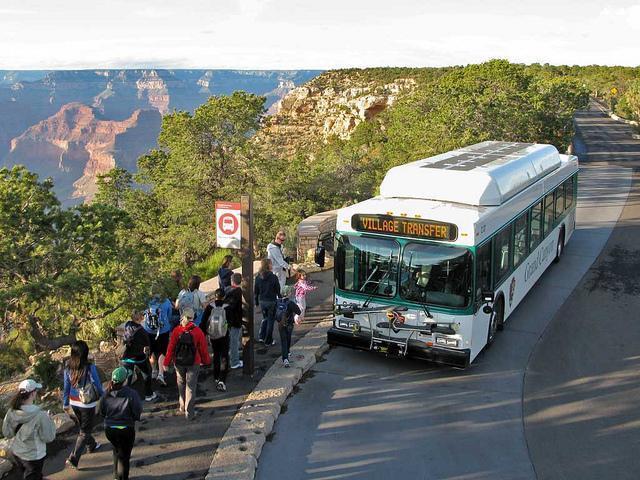How many buses are there?
Give a very brief answer. 1. How many people can be seen?
Give a very brief answer. 5. 